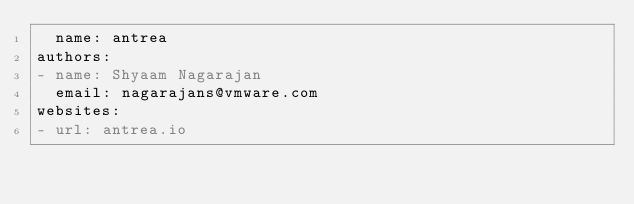Convert code to text. <code><loc_0><loc_0><loc_500><loc_500><_YAML_>  name: antrea
authors:
- name: Shyaam Nagarajan
  email: nagarajans@vmware.com
websites:
- url: antrea.io
</code> 